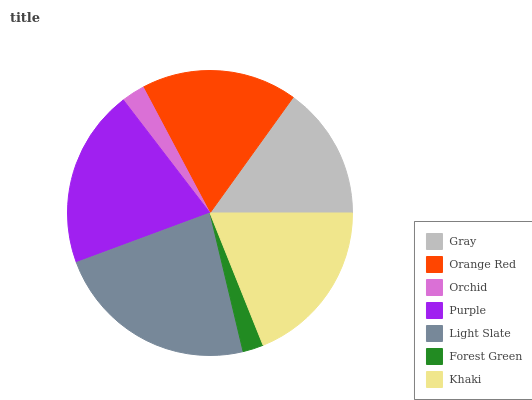Is Forest Green the minimum?
Answer yes or no. Yes. Is Light Slate the maximum?
Answer yes or no. Yes. Is Orange Red the minimum?
Answer yes or no. No. Is Orange Red the maximum?
Answer yes or no. No. Is Orange Red greater than Gray?
Answer yes or no. Yes. Is Gray less than Orange Red?
Answer yes or no. Yes. Is Gray greater than Orange Red?
Answer yes or no. No. Is Orange Red less than Gray?
Answer yes or no. No. Is Orange Red the high median?
Answer yes or no. Yes. Is Orange Red the low median?
Answer yes or no. Yes. Is Light Slate the high median?
Answer yes or no. No. Is Gray the low median?
Answer yes or no. No. 